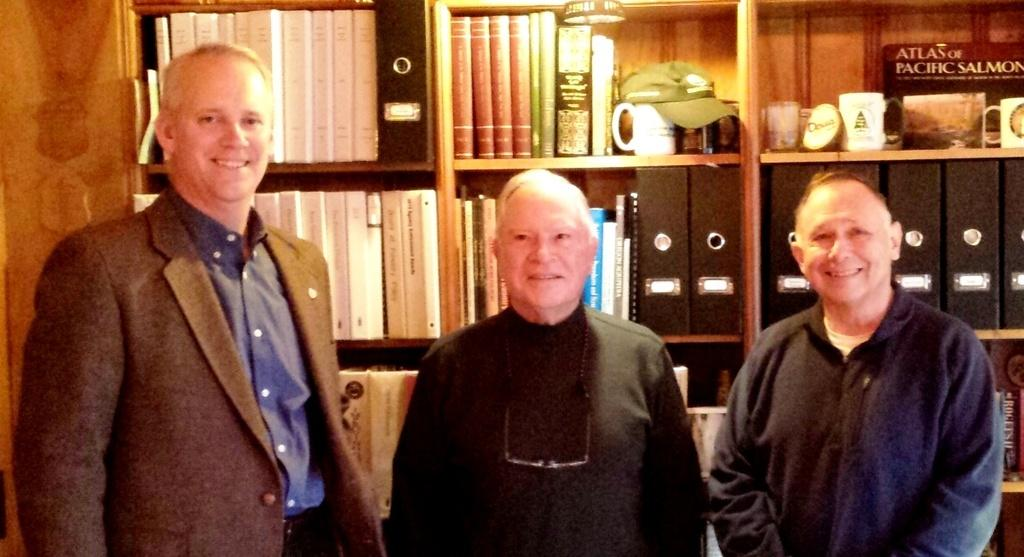How many persons are in the image? There are persons in the image, but the exact number is not specified. What can be seen in the background of the image? In the background of the image, there are books, cups, shelves, and other objects. There is also a wooden texture. What might the shelves be used for? The shelves in the background of the image might be used for storing or displaying books, cups, or other objects. How does the image increase the power of the person viewing it? The image does not have the ability to increase the power of the person viewing it; it is simply a visual representation of a scene. 